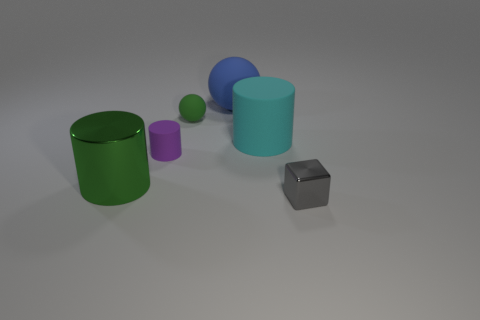There is a cylinder that is behind the small purple cylinder; is its size the same as the green thing behind the small purple matte object?
Offer a very short reply. No. How many things are either large green metal objects left of the big cyan rubber object or green objects?
Provide a succinct answer. 2. Are there fewer metal cylinders than small yellow things?
Your answer should be very brief. No. There is a big matte thing to the left of the rubber cylinder to the right of the tiny purple rubber cylinder in front of the green rubber ball; what is its shape?
Make the answer very short. Sphere. What shape is the other object that is the same color as the large metallic object?
Give a very brief answer. Sphere. Are any large red rubber blocks visible?
Offer a very short reply. No. Do the gray block and the shiny thing that is to the left of the cyan cylinder have the same size?
Your answer should be very brief. No. Is there a small green thing on the left side of the metallic object that is behind the gray block?
Your answer should be very brief. No. There is a thing that is in front of the small purple cylinder and behind the tiny block; what material is it made of?
Make the answer very short. Metal. What is the color of the metallic object that is behind the metal thing that is to the right of the green thing that is on the right side of the green shiny cylinder?
Provide a succinct answer. Green. 